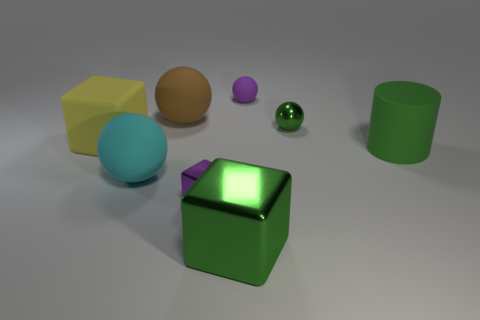Is there any other thing that is the same shape as the purple metal thing?
Make the answer very short. Yes. Are there any big brown matte spheres to the right of the purple thing that is in front of the rubber cube?
Give a very brief answer. No. Are there fewer large matte cubes that are in front of the large yellow thing than green rubber cylinders that are left of the green rubber cylinder?
Keep it short and to the point. No. There is a purple thing that is behind the matte ball that is in front of the metal object behind the yellow cube; what is its size?
Provide a succinct answer. Small. Is the size of the green object on the left side of the shiny ball the same as the large brown rubber object?
Provide a short and direct response. Yes. How many other things are made of the same material as the cyan thing?
Provide a short and direct response. 4. Is the number of small blocks greater than the number of brown rubber cylinders?
Offer a very short reply. Yes. What material is the purple thing that is to the left of the big cube that is in front of the big matte thing that is to the right of the purple shiny block?
Provide a succinct answer. Metal. Is the color of the small metal sphere the same as the cylinder?
Ensure brevity in your answer.  Yes. Is there a big rubber cylinder of the same color as the tiny shiny block?
Offer a very short reply. No. 